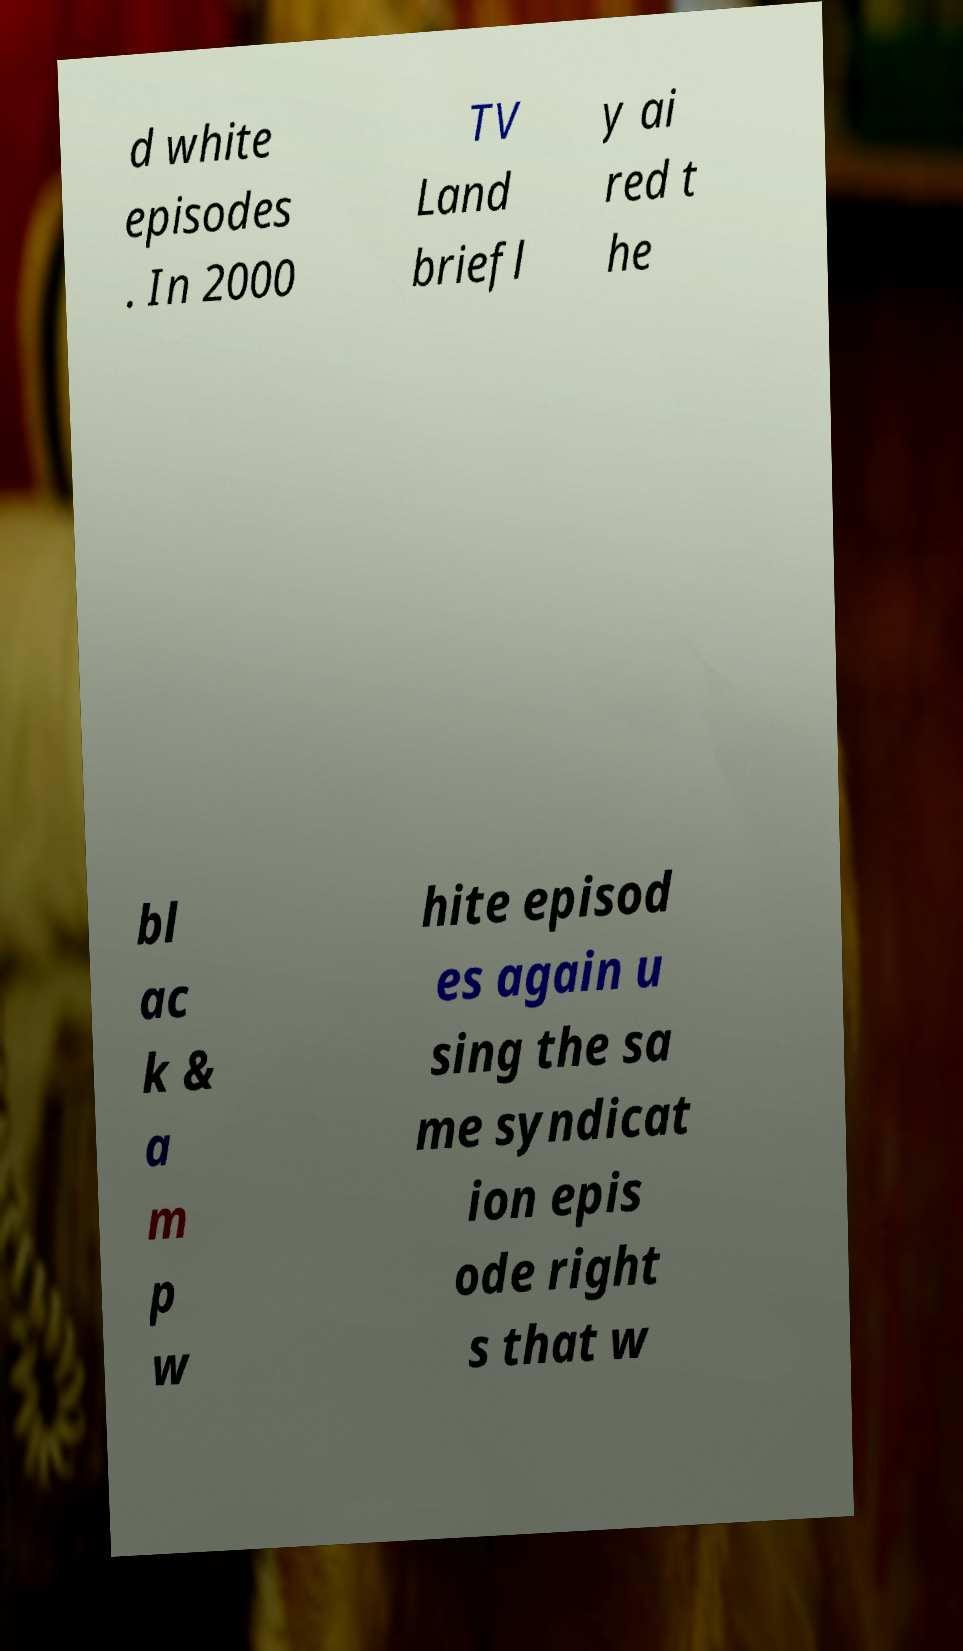Could you extract and type out the text from this image? d white episodes . In 2000 TV Land briefl y ai red t he bl ac k & a m p w hite episod es again u sing the sa me syndicat ion epis ode right s that w 